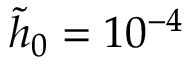<formula> <loc_0><loc_0><loc_500><loc_500>\tilde { h } _ { 0 } = 1 0 ^ { - 4 }</formula> 